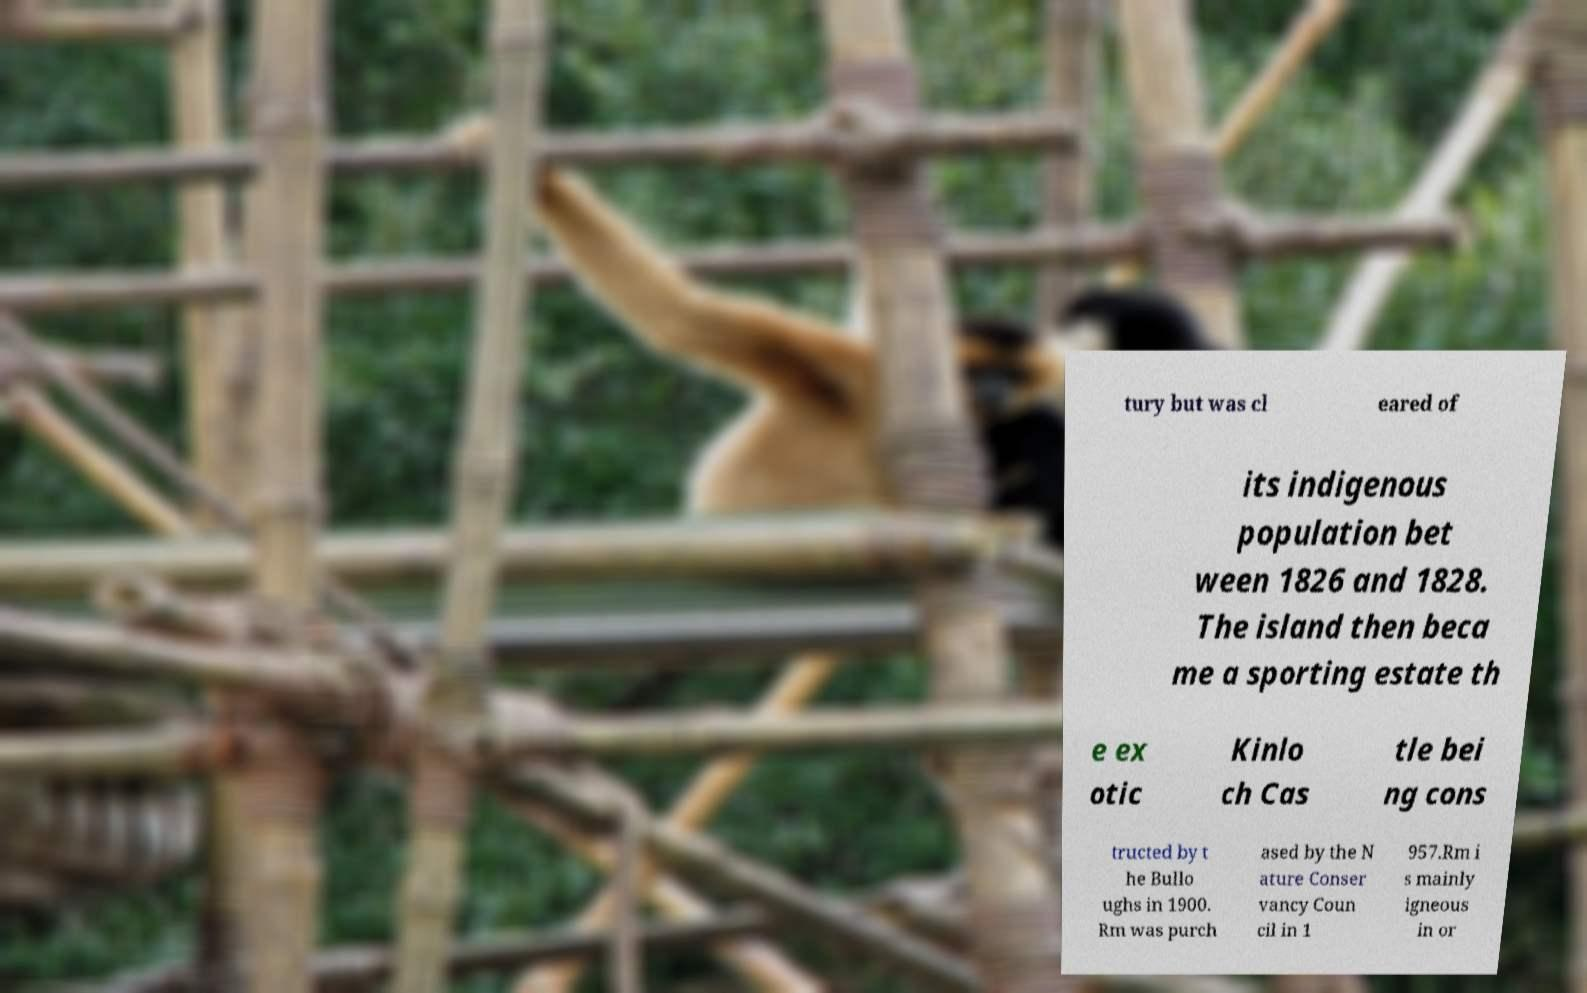What messages or text are displayed in this image? I need them in a readable, typed format. tury but was cl eared of its indigenous population bet ween 1826 and 1828. The island then beca me a sporting estate th e ex otic Kinlo ch Cas tle bei ng cons tructed by t he Bullo ughs in 1900. Rm was purch ased by the N ature Conser vancy Coun cil in 1 957.Rm i s mainly igneous in or 